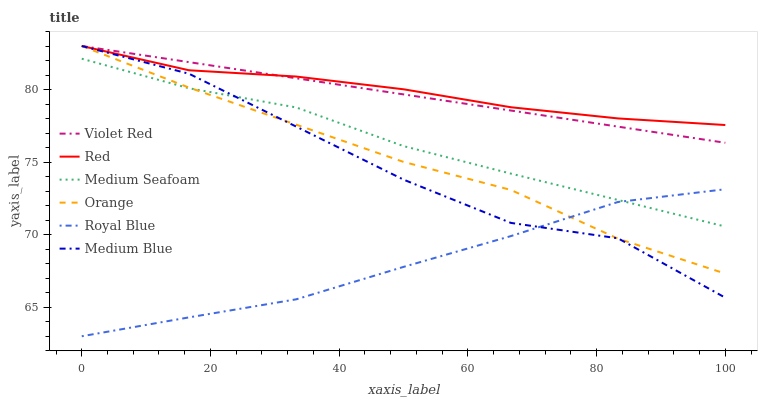Does Royal Blue have the minimum area under the curve?
Answer yes or no. Yes. Does Red have the maximum area under the curve?
Answer yes or no. Yes. Does Medium Blue have the minimum area under the curve?
Answer yes or no. No. Does Medium Blue have the maximum area under the curve?
Answer yes or no. No. Is Violet Red the smoothest?
Answer yes or no. Yes. Is Medium Blue the roughest?
Answer yes or no. Yes. Is Royal Blue the smoothest?
Answer yes or no. No. Is Royal Blue the roughest?
Answer yes or no. No. Does Royal Blue have the lowest value?
Answer yes or no. Yes. Does Medium Blue have the lowest value?
Answer yes or no. No. Does Red have the highest value?
Answer yes or no. Yes. Does Royal Blue have the highest value?
Answer yes or no. No. Is Royal Blue less than Red?
Answer yes or no. Yes. Is Violet Red greater than Medium Seafoam?
Answer yes or no. Yes. Does Violet Red intersect Orange?
Answer yes or no. Yes. Is Violet Red less than Orange?
Answer yes or no. No. Is Violet Red greater than Orange?
Answer yes or no. No. Does Royal Blue intersect Red?
Answer yes or no. No. 